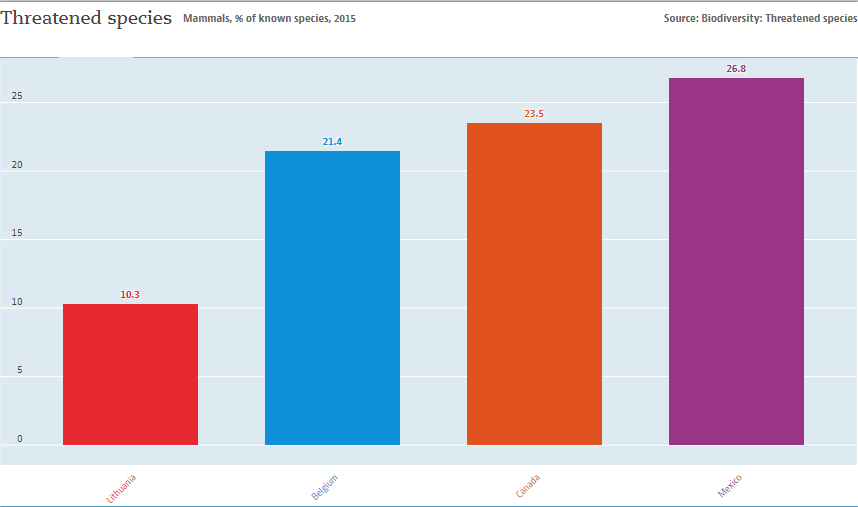Give some essential details in this illustration. The value of the largest bar is 26.8. The largest and smallest bars have a difference in value of 16.5. 